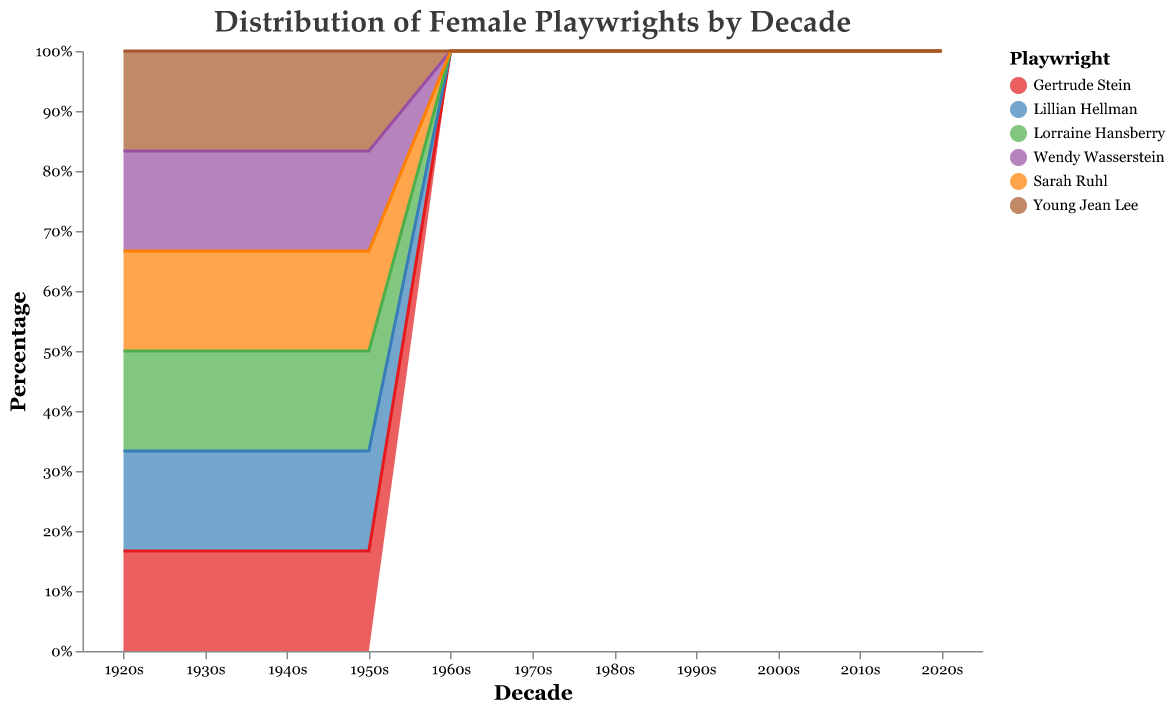What is the title of the chart? The title of the chart is displayed at the top and reads "Distribution of Female Playwrights by Decade".
Answer: Distribution of Female Playwrights by Decade Which playwright had the highest percentage in the 1950s? To find this, we look at the 1950s category and identify which playwright occupies the largest area. The 1950s show that Lillian Hellman has the highest percentage.
Answer: Lillian Hellman In which decade did Sarah Ruhl first appear? We can see the appearance of Sarah Ruhl by locating her respective color in the area chart. Sarah Ruhl first appears in the 2000s.
Answer: 2000s How did the percentage contribution of Lorraine Hansberry change from the 1960s to the 1970s? In the 1960s, Lorraine Hansberry had a certain percentage and in the 1970s, it increased to a higher percentage. Specifically, her contribution goes from 25% in the 1960s to 45% in the 1970s.
Answer: increased How many decades did Gertrude Stein contribute to the chart? To find this, we look for the presence of her corresponding color across the decades. Gertrude Stein has contributions in the 1920s, 1930s, 1940s, and 1950s.
Answer: 4 Who had the largest percentage contribution in 2020s? To find the largest percentage in the 2020s, look at the respective layers of the area chart. Young Jean Lee occupies the largest area in the 2020s.
Answer: Young Jean Lee What is Lillian Hellman’s percentage contribution in the 1940s? By observing the 1940s section, we can measure the stacked area representing Lillian Hellman’s percentage. Lillian Hellman contributed 35% in the 1940s.
Answer: 35% Compare the percentage contributions of Wendy Wasserstein in the 1980s and the 1990s. To compare, observe Wendy Wasserstein’s areas in the 1980s and 1990s, and find that she has 25% in the 1980s and 40% in the 1990s. Wendy Wasserstein’s percentage increased from 25% to 40%.
Answer: increased Which two playwrights contributed in the highest percentage in the 2010s? In the 2010s, the areas representing the contributions of Sarah Ruhl and Young Jean Lee are the two largest.
Answer: Sarah Ruhl and Young Jean Lee Which playwright only appeared in one decade? To identify this, look for the presence of a playwright in a single decade. Lorraine Hansberry only appeared in the 1960s and 1970s. Wendy Wasserstein appears in the 1980s, 1990s, and 2000s. Sarah Ruhl appears in the 2000s, 2010s, and 2020s. Young Jean Lee only appeared in the 2010s and 2020s, Lillian Hellman more than two, and Gertrude Stein in more of the decades. Therefore, Lorraine Hansberry and Young Jean Lee.
Answer: Lorraine Hansberry and Young Jean Lee 